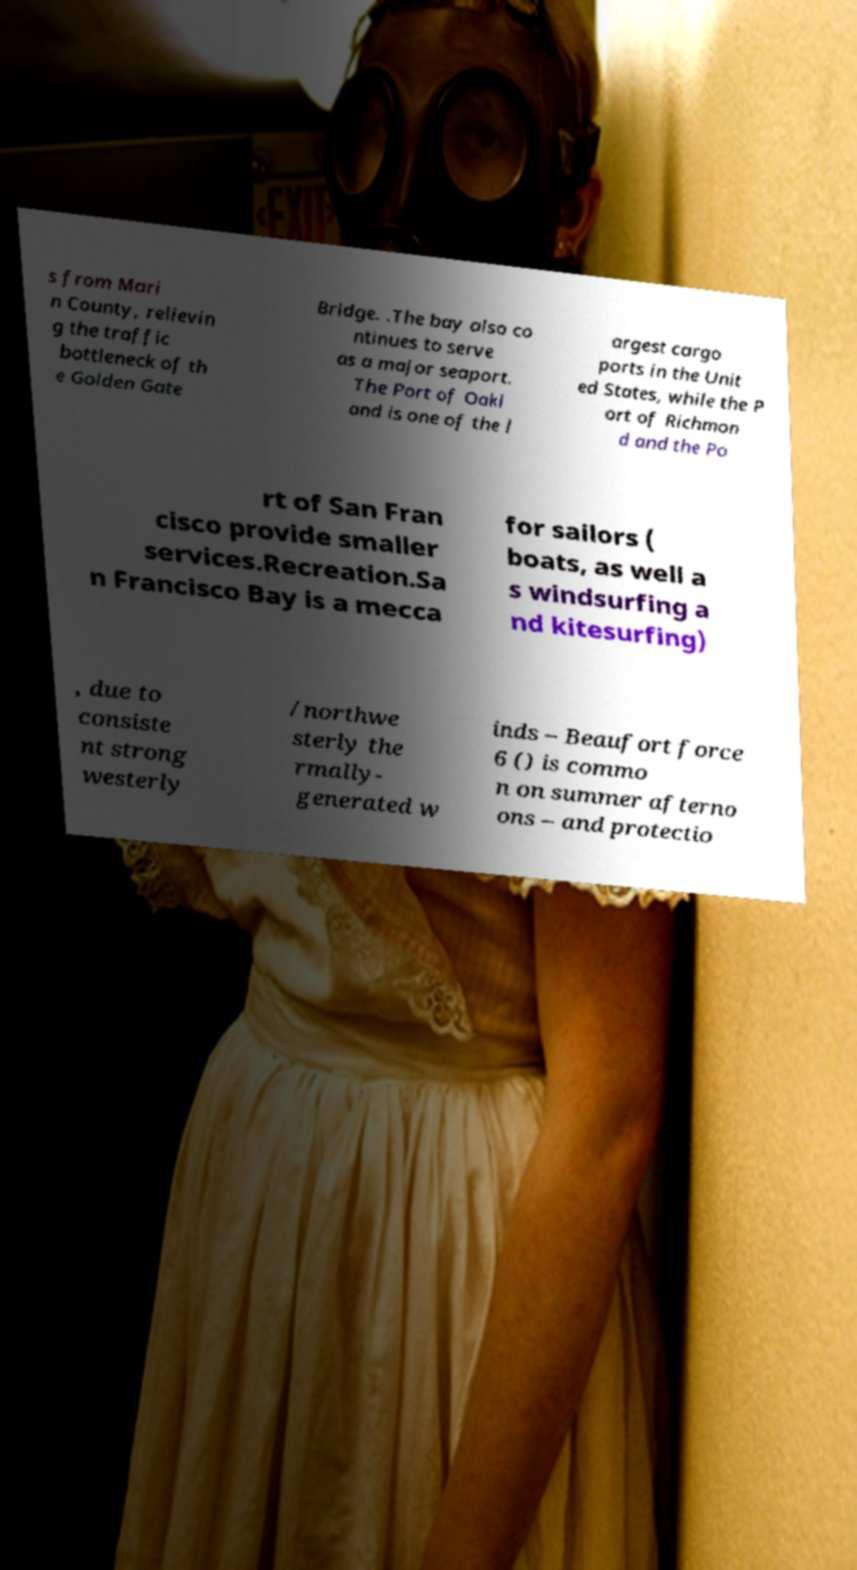Could you assist in decoding the text presented in this image and type it out clearly? s from Mari n County, relievin g the traffic bottleneck of th e Golden Gate Bridge. .The bay also co ntinues to serve as a major seaport. The Port of Oakl and is one of the l argest cargo ports in the Unit ed States, while the P ort of Richmon d and the Po rt of San Fran cisco provide smaller services.Recreation.Sa n Francisco Bay is a mecca for sailors ( boats, as well a s windsurfing a nd kitesurfing) , due to consiste nt strong westerly /northwe sterly the rmally- generated w inds – Beaufort force 6 () is commo n on summer afterno ons – and protectio 